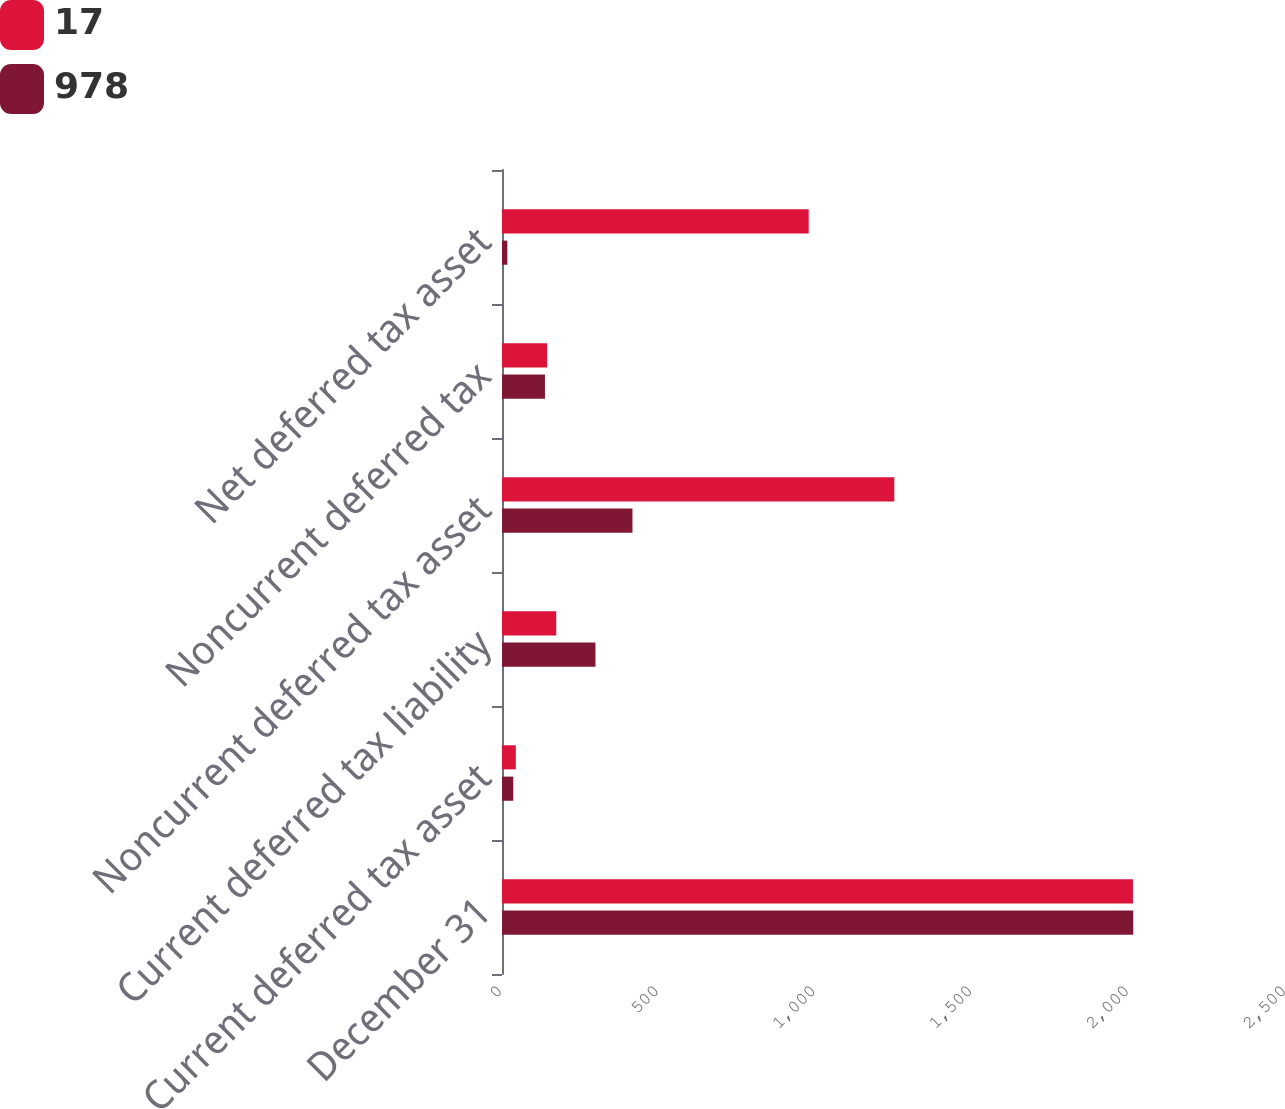Convert chart to OTSL. <chart><loc_0><loc_0><loc_500><loc_500><stacked_bar_chart><ecel><fcel>December 31<fcel>Current deferred tax asset<fcel>Current deferred tax liability<fcel>Noncurrent deferred tax asset<fcel>Noncurrent deferred tax<fcel>Net deferred tax asset<nl><fcel>17<fcel>2012<fcel>44<fcel>173<fcel>1251<fcel>144<fcel>978<nl><fcel>978<fcel>2013<fcel>36<fcel>298<fcel>416<fcel>137<fcel>17<nl></chart> 